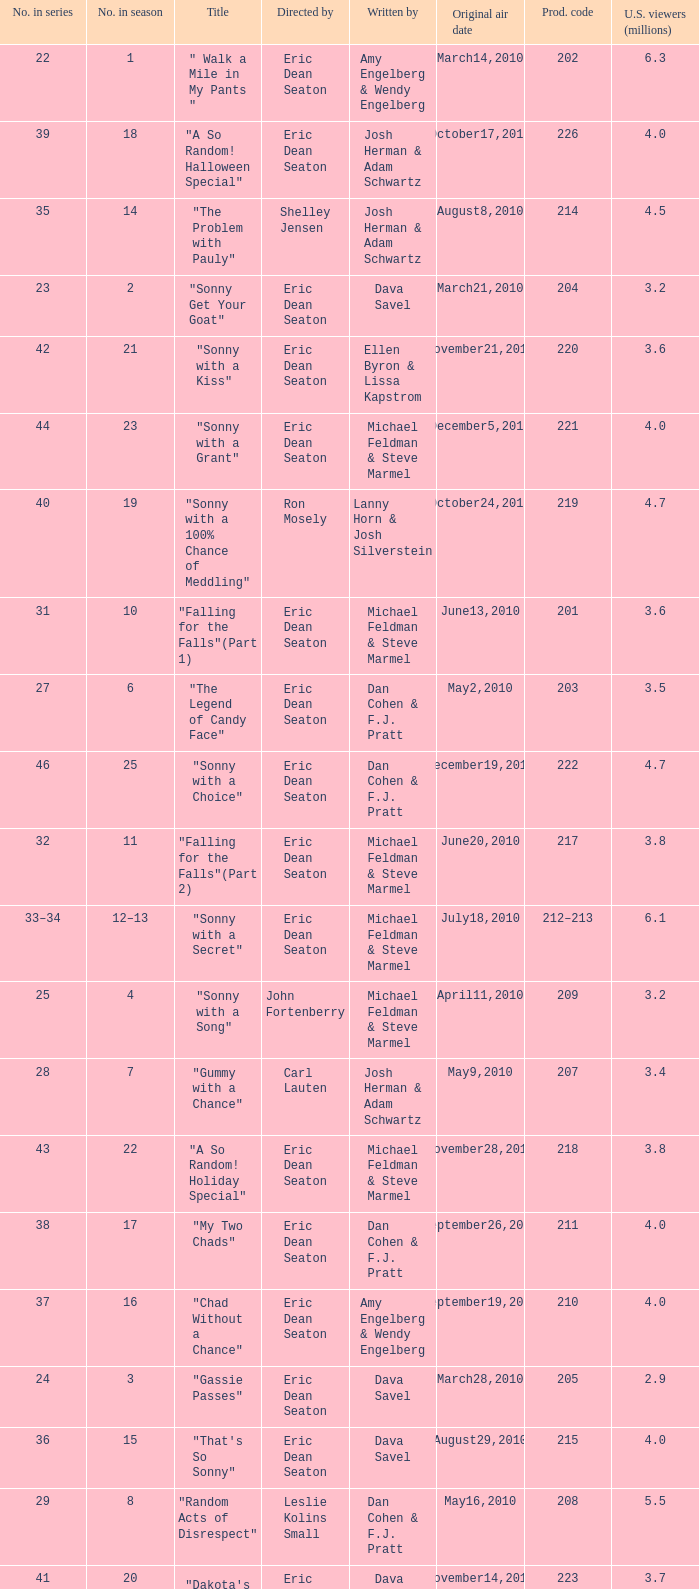Who directed the episode that 6.3 million u.s. viewers saw? Eric Dean Seaton. 